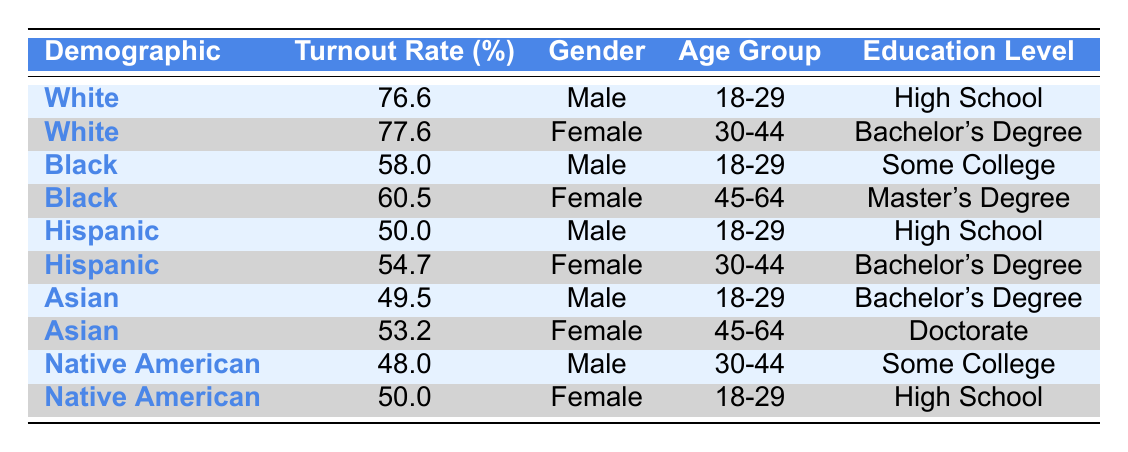What is the voter turnout rate for White females aged 30-44 with a Bachelor's Degree? Referring to the table, the entry for White females aged 30-44 with a Bachelor's Degree shows a turnout rate of 77.6%.
Answer: 77.6% Which demographic group has the lowest voter turnout rate among males in the 18-29 age group? The turnout rates for males in the 18-29 age group are: White 76.6%, Black 58.0%, Hispanic 50.0%, and Asian 49.5%. The lowest of these is 49.5% for Asian males.
Answer: Asian What is the difference in voter turnout rates between Black females aged 45-64 with a Master's Degree and Hispanic females aged 30-44 with a Bachelor's Degree? The turnout rate for Black females aged 45-64 is 60.5%, and for Hispanic females aged 30-44 is 54.7%. The difference is 60.5% - 54.7% = 5.8%.
Answer: 5.8% Is it true that Hispanic males have a higher turnout rate than Asian males in the 18-29 age group? The turnout rate for Hispanic males is 50.0% and for Asian males is 49.5%. Since 50.0% is greater than 49.5%, the statement is true.
Answer: Yes What is the average voter turnout rate for females in the 30-44 age group across all demographic groups? The turnout rates for females in the 30-44 age group are: White 77.6%, Hispanic 54.7%. The average is (77.6 + 54.7) / 2 = 66.15%.
Answer: 66.15% Which demographic group has the highest turnout rate for females aged 45-64 with a Doctorate degree? The only demographic group listed for females aged 45-64 with a Doctorate degree is Asian, with a turnout rate of 53.2%. Thus, Asian has the highest rate in this group.
Answer: Asian What is the total voter turnout rate for Native American females and males? The turnout rates are 50.0% for Native American females and 48.0% for Native American males. The total is 50.0% + 48.0% = 98.0%.
Answer: 98.0% Is the voter turnout rate for White males aged 18-29 higher than that for Hispanic males aged 18-29? The voter turnout rate for White males is 76.6% and for Hispanic males is 50.0%. Since 76.6% is greater than 50.0%, the statement is true.
Answer: Yes What is the median voter turnout rate among all demographic groups listed for males? The turnout rates for males are: 76.6% (White), 58.0% (Black), 50.0% (Hispanic), 49.5% (Asian), and 48.0% (Native American). Arranging these rates in order gives us: 48.0%, 49.5%, 50.0%, 58.0%, 76.6%. The median is the middle value, which is 50.0%.
Answer: 50.0% 